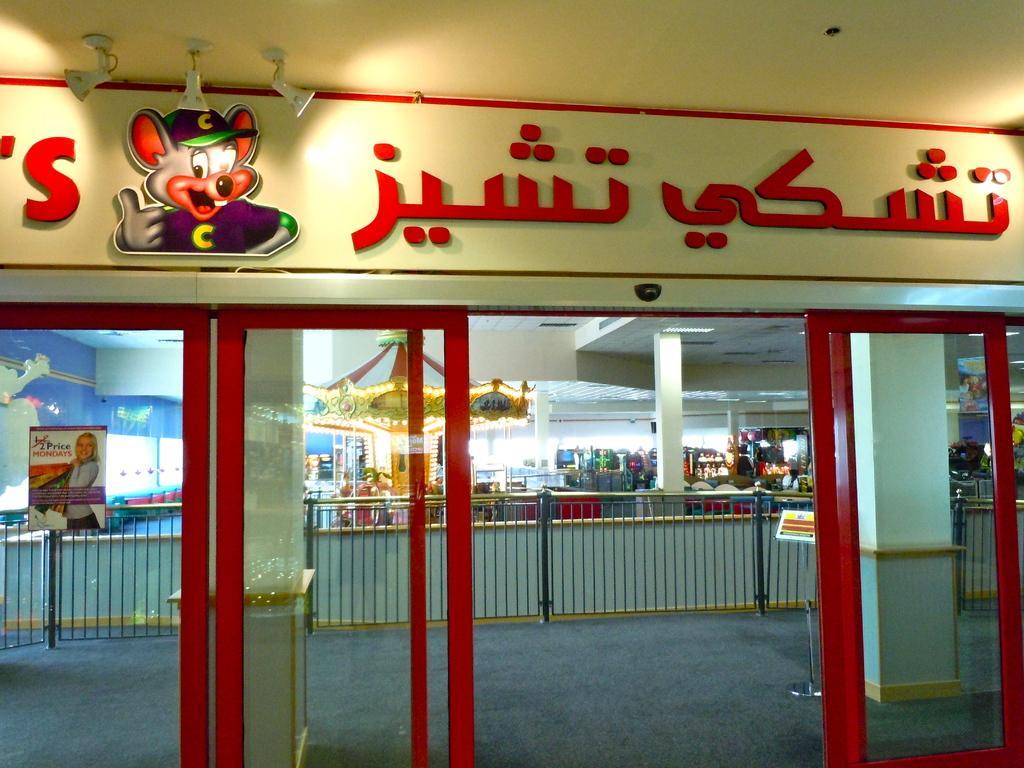Describe this image in one or two sentences. Here in this picture we can see a store front, as we can see doors and on the wall we can see some picture and text present and inside that we can see barricades present and we can also see a merry go round and we can see banners and some other things also present and we can also see pillars present and we can see lights on the roof present. 